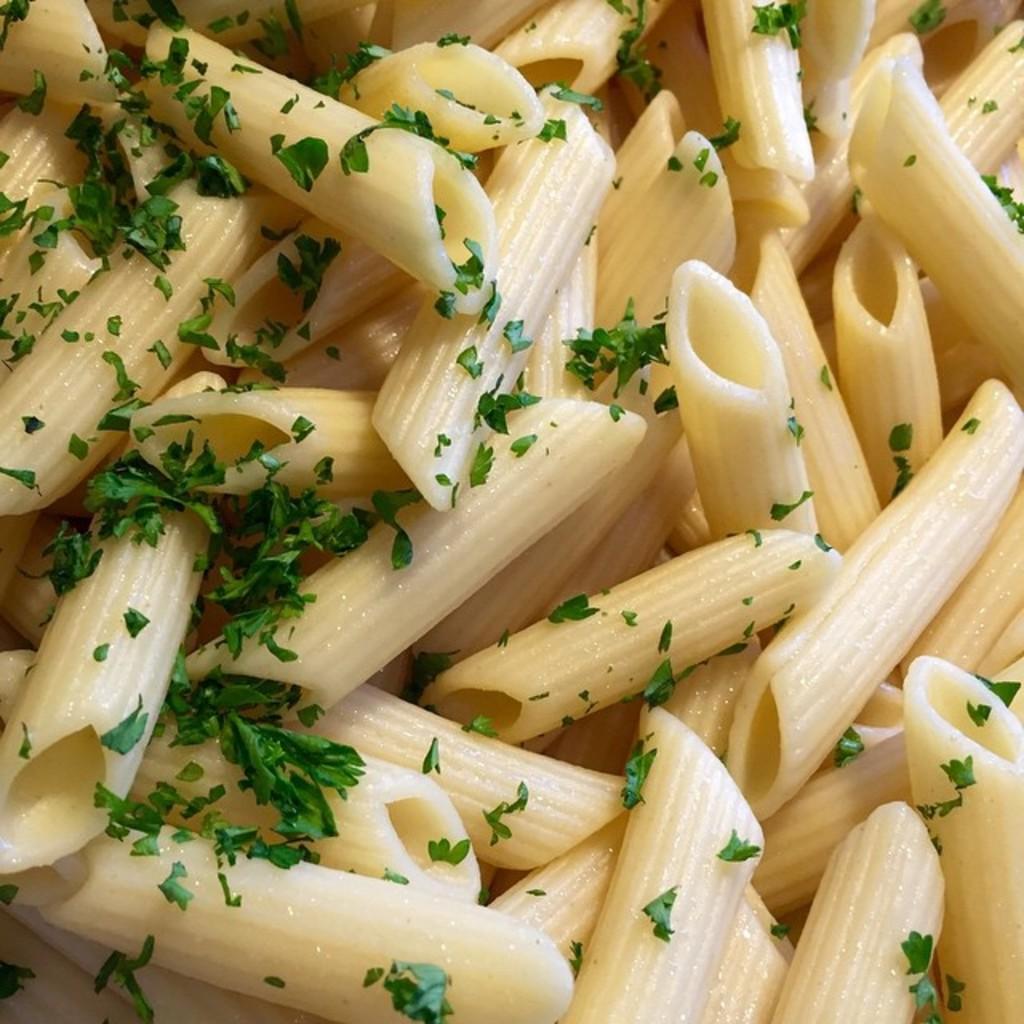In one or two sentences, can you explain what this image depicts? In this image we can see pasta and some coriander leaves sprinkled on it. 